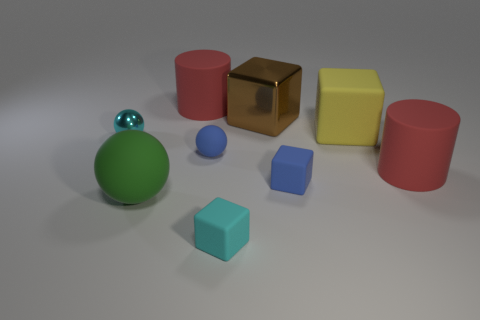What material is the blue object that is the same shape as the large green thing?
Ensure brevity in your answer.  Rubber. How many cyan balls have the same size as the cyan rubber cube?
Keep it short and to the point. 1. There is a small sphere that is made of the same material as the blue cube; what is its color?
Ensure brevity in your answer.  Blue. Are there fewer tiny spheres than big purple spheres?
Give a very brief answer. No. How many red things are tiny matte cubes or big rubber cylinders?
Give a very brief answer. 2. How many big matte things are both in front of the yellow cube and to the right of the big metal cube?
Keep it short and to the point. 1. Is the material of the large brown object the same as the cyan sphere?
Keep it short and to the point. Yes. There is a yellow rubber object that is the same size as the brown metallic object; what shape is it?
Your answer should be compact. Cube. Is the number of yellow rubber things greater than the number of big yellow metal cylinders?
Provide a short and direct response. Yes. There is a big thing that is right of the big green matte thing and in front of the yellow thing; what is it made of?
Your answer should be compact. Rubber. 